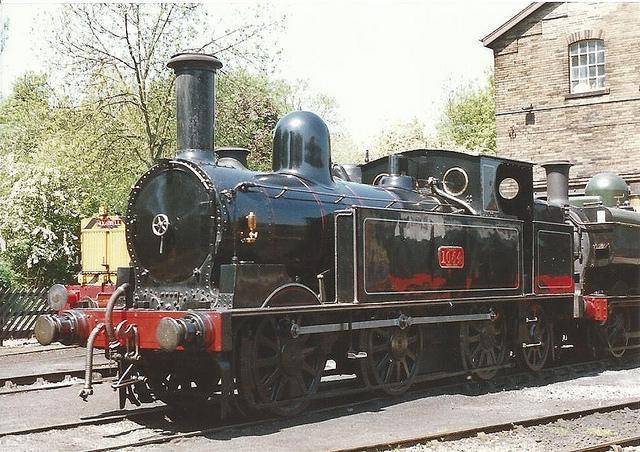How many trains are in the photo?
Give a very brief answer. 1. How many people in the picture are wearing black caps?
Give a very brief answer. 0. 